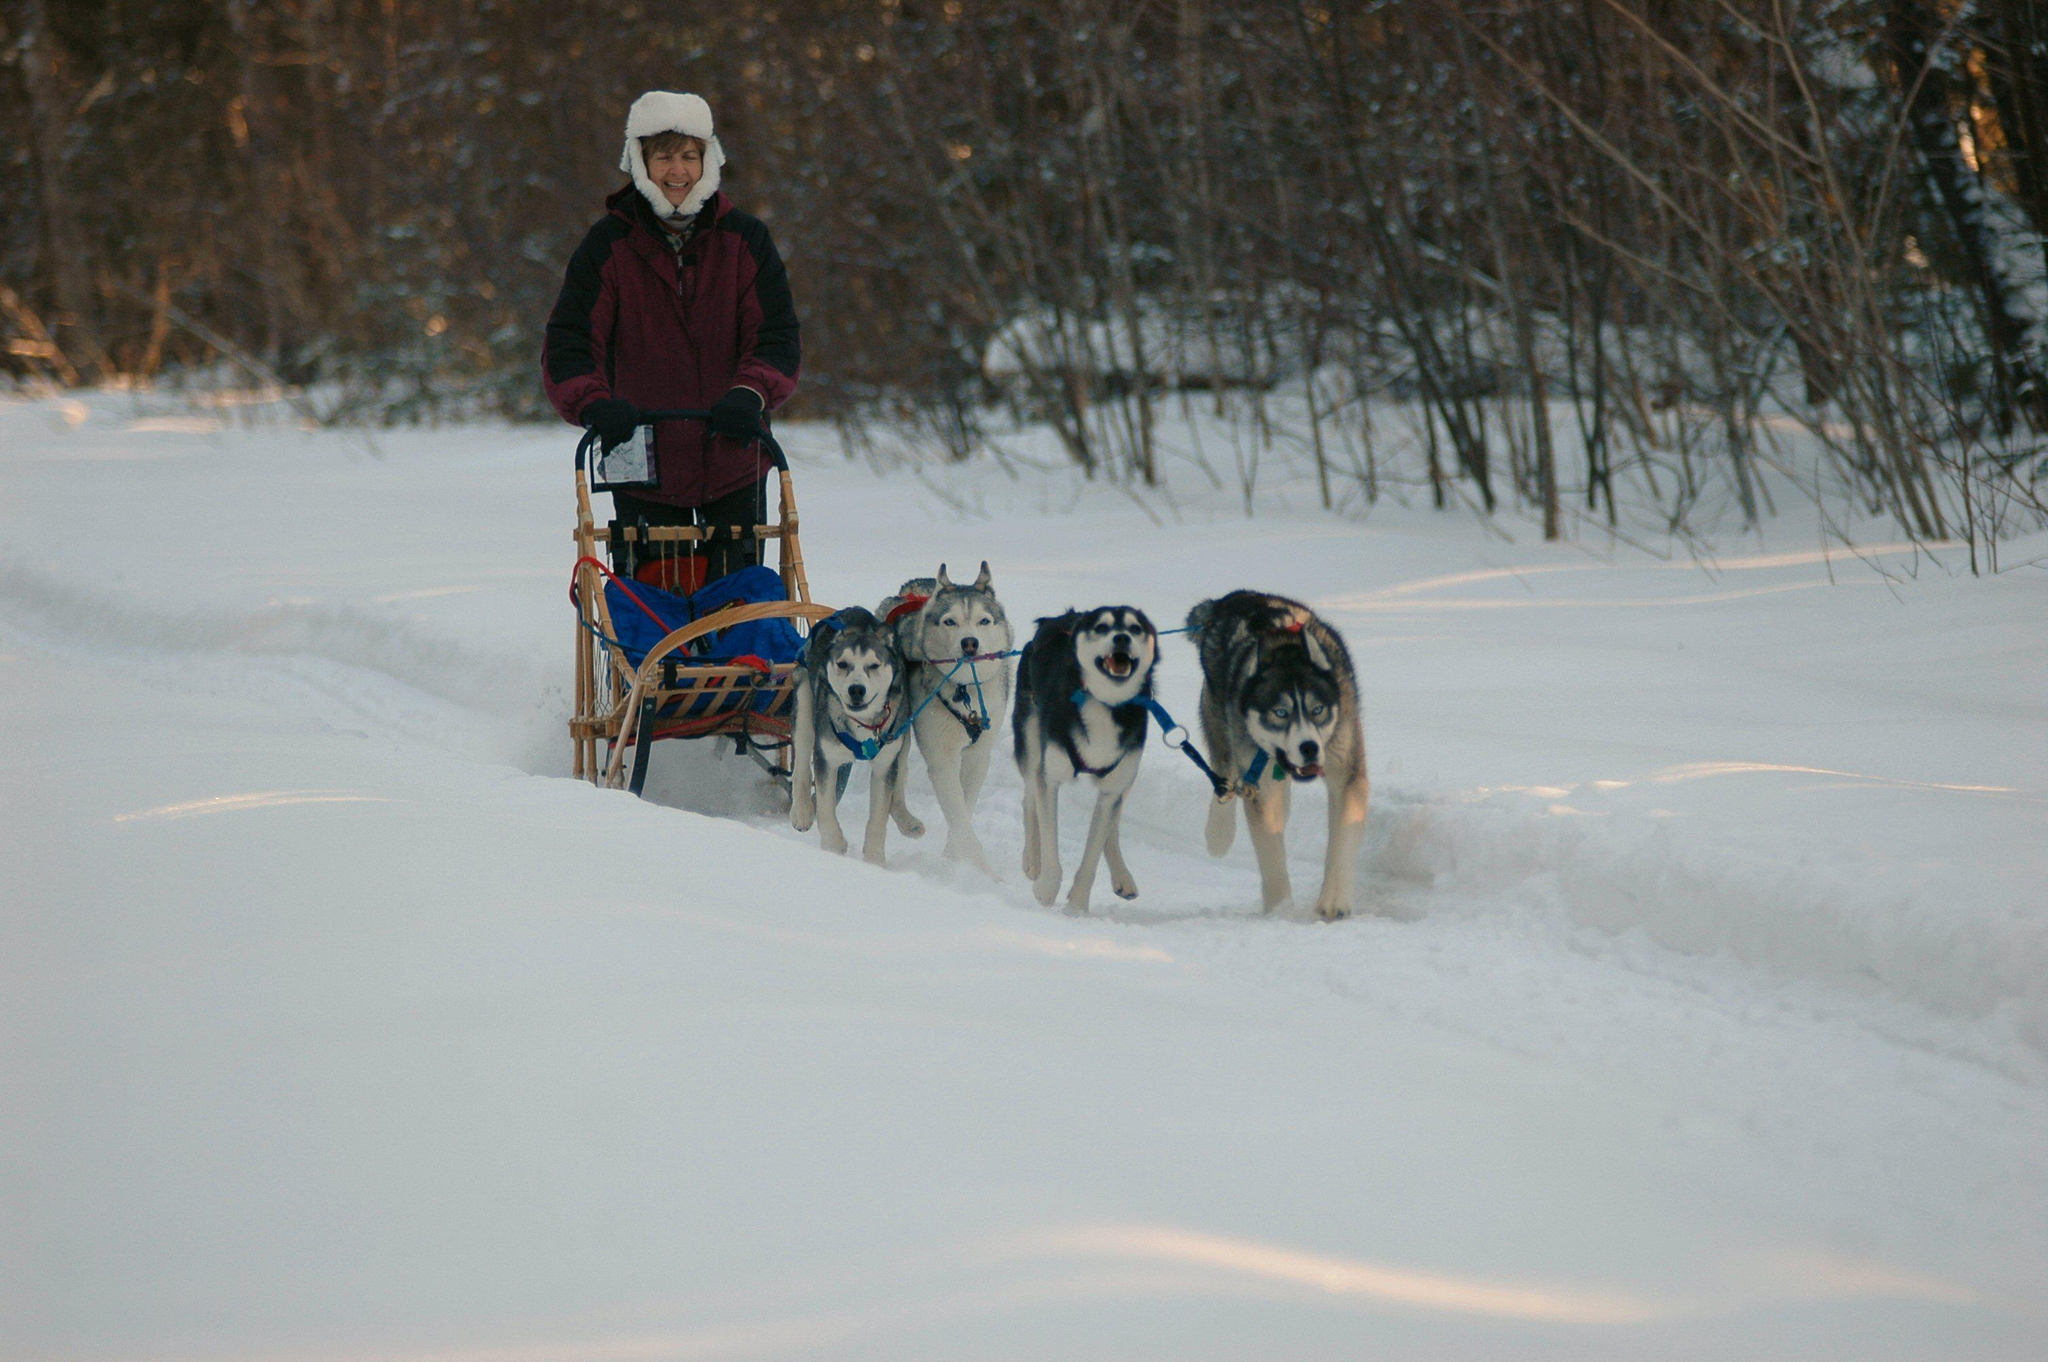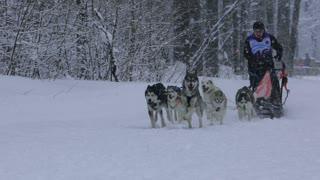The first image is the image on the left, the second image is the image on the right. For the images displayed, is the sentence "One image shows a team of dogs heading away from the camera toward a background of mountains." factually correct? Answer yes or no. No. The first image is the image on the left, the second image is the image on the right. Analyze the images presented: Is the assertion "In one of the images, at least one dog on a leash is anchored to the waist of a person on skis." valid? Answer yes or no. No. 